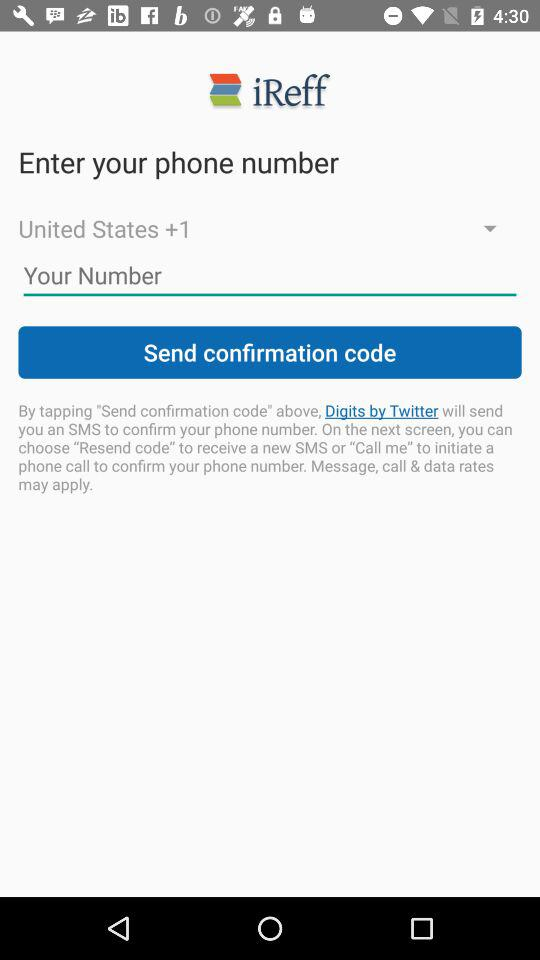Which country is selected? The selected country is the United States. 